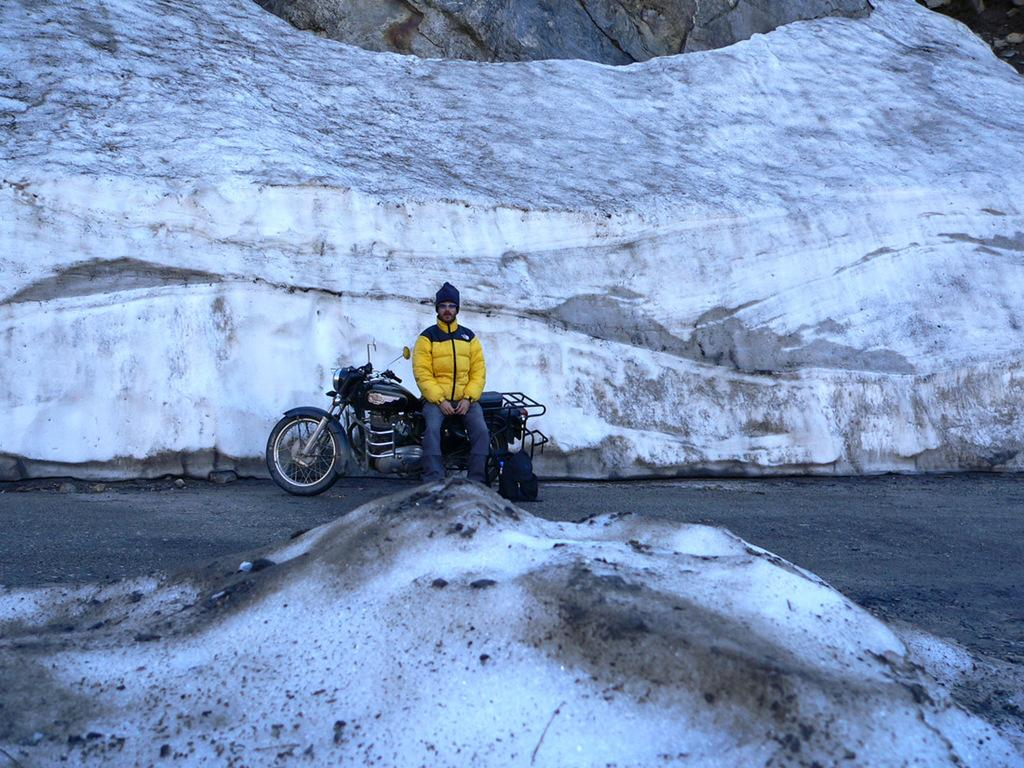What is the main feature of the image? There is snow in the image. Can you describe the man in the background? The man is sitting on a bike in the background, and he is on the road. What is the man holding or carrying? The man has a bag at his legs. What other large object can be seen in the image? There is a big ice rock in the image. What else is present in the image? There is an object in the image. How many kittens are playing with a button in the snow? There are no kittens or buttons present in the image; it features snow, a man on a bike, a bag, a big ice rock, and an unspecified object. 